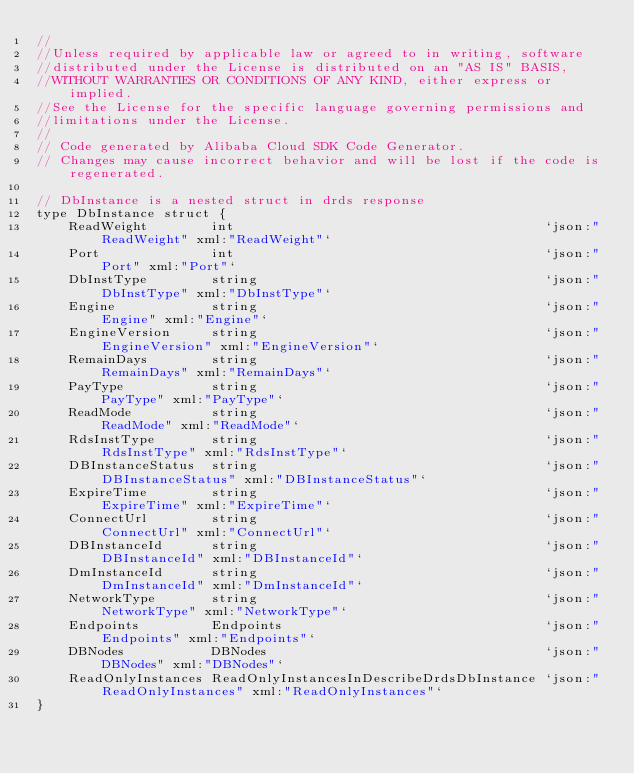<code> <loc_0><loc_0><loc_500><loc_500><_Go_>//
//Unless required by applicable law or agreed to in writing, software
//distributed under the License is distributed on an "AS IS" BASIS,
//WITHOUT WARRANTIES OR CONDITIONS OF ANY KIND, either express or implied.
//See the License for the specific language governing permissions and
//limitations under the License.
//
// Code generated by Alibaba Cloud SDK Code Generator.
// Changes may cause incorrect behavior and will be lost if the code is regenerated.

// DbInstance is a nested struct in drds response
type DbInstance struct {
	ReadWeight        int                                       `json:"ReadWeight" xml:"ReadWeight"`
	Port              int                                       `json:"Port" xml:"Port"`
	DbInstType        string                                    `json:"DbInstType" xml:"DbInstType"`
	Engine            string                                    `json:"Engine" xml:"Engine"`
	EngineVersion     string                                    `json:"EngineVersion" xml:"EngineVersion"`
	RemainDays        string                                    `json:"RemainDays" xml:"RemainDays"`
	PayType           string                                    `json:"PayType" xml:"PayType"`
	ReadMode          string                                    `json:"ReadMode" xml:"ReadMode"`
	RdsInstType       string                                    `json:"RdsInstType" xml:"RdsInstType"`
	DBInstanceStatus  string                                    `json:"DBInstanceStatus" xml:"DBInstanceStatus"`
	ExpireTime        string                                    `json:"ExpireTime" xml:"ExpireTime"`
	ConnectUrl        string                                    `json:"ConnectUrl" xml:"ConnectUrl"`
	DBInstanceId      string                                    `json:"DBInstanceId" xml:"DBInstanceId"`
	DmInstanceId      string                                    `json:"DmInstanceId" xml:"DmInstanceId"`
	NetworkType       string                                    `json:"NetworkType" xml:"NetworkType"`
	Endpoints         Endpoints                                 `json:"Endpoints" xml:"Endpoints"`
	DBNodes           DBNodes                                   `json:"DBNodes" xml:"DBNodes"`
	ReadOnlyInstances ReadOnlyInstancesInDescribeDrdsDbInstance `json:"ReadOnlyInstances" xml:"ReadOnlyInstances"`
}
</code> 